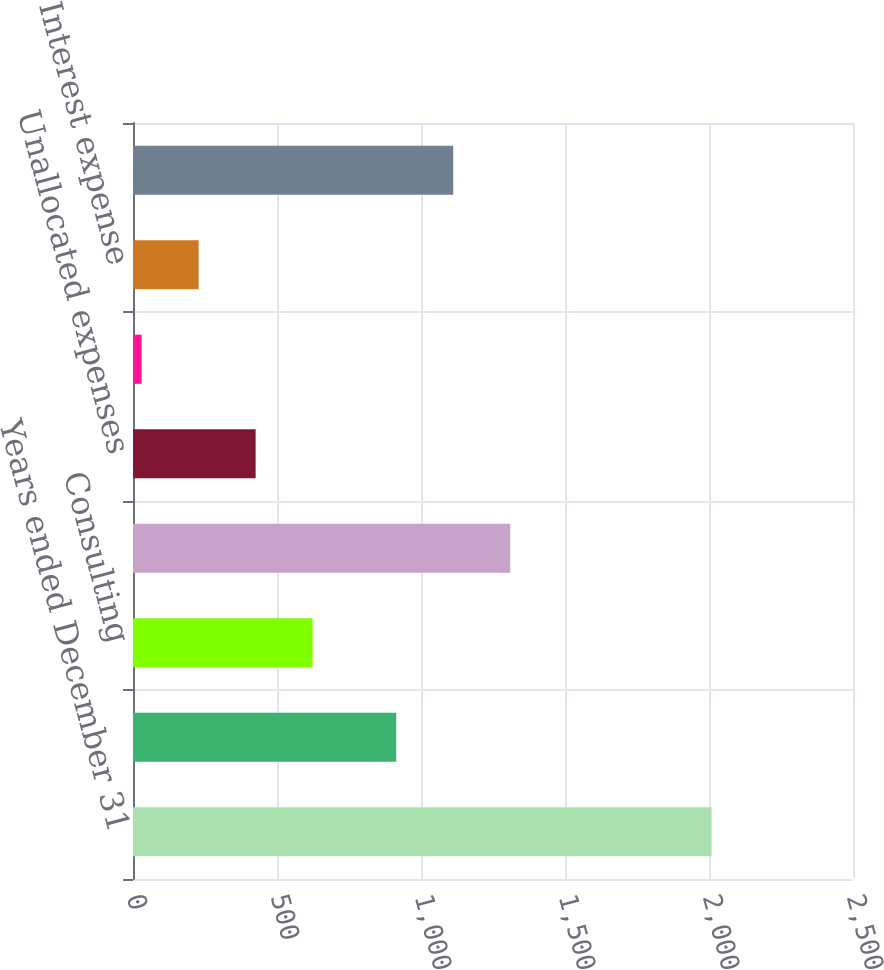<chart> <loc_0><loc_0><loc_500><loc_500><bar_chart><fcel>Years ended December 31<fcel>Risk and Insurance Brokerage<fcel>Consulting<fcel>Segment income from continuing<fcel>Unallocated expenses<fcel>Interest income<fcel>Interest expense<fcel>Income from continuing<nl><fcel>2009<fcel>914<fcel>623.7<fcel>1309.8<fcel>425.8<fcel>30<fcel>227.9<fcel>1111.9<nl></chart> 